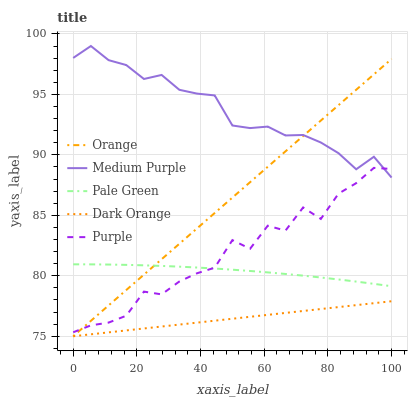Does Dark Orange have the minimum area under the curve?
Answer yes or no. Yes. Does Medium Purple have the maximum area under the curve?
Answer yes or no. Yes. Does Pale Green have the minimum area under the curve?
Answer yes or no. No. Does Pale Green have the maximum area under the curve?
Answer yes or no. No. Is Dark Orange the smoothest?
Answer yes or no. Yes. Is Purple the roughest?
Answer yes or no. Yes. Is Medium Purple the smoothest?
Answer yes or no. No. Is Medium Purple the roughest?
Answer yes or no. No. Does Orange have the lowest value?
Answer yes or no. Yes. Does Pale Green have the lowest value?
Answer yes or no. No. Does Medium Purple have the highest value?
Answer yes or no. Yes. Does Pale Green have the highest value?
Answer yes or no. No. Is Pale Green less than Medium Purple?
Answer yes or no. Yes. Is Pale Green greater than Dark Orange?
Answer yes or no. Yes. Does Pale Green intersect Purple?
Answer yes or no. Yes. Is Pale Green less than Purple?
Answer yes or no. No. Is Pale Green greater than Purple?
Answer yes or no. No. Does Pale Green intersect Medium Purple?
Answer yes or no. No. 